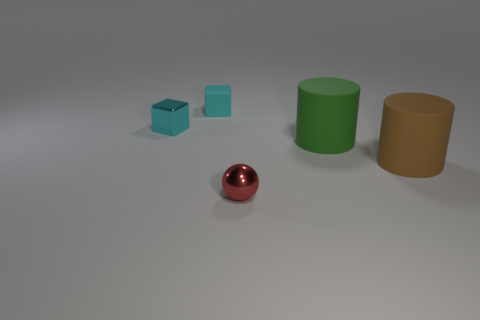Add 1 green cylinders. How many objects exist? 6 Subtract all spheres. How many objects are left? 4 Subtract all big red rubber cylinders. Subtract all big green matte objects. How many objects are left? 4 Add 2 big things. How many big things are left? 4 Add 4 brown things. How many brown things exist? 5 Subtract 0 cyan cylinders. How many objects are left? 5 